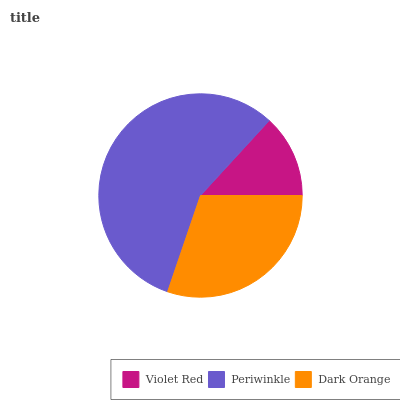Is Violet Red the minimum?
Answer yes or no. Yes. Is Periwinkle the maximum?
Answer yes or no. Yes. Is Dark Orange the minimum?
Answer yes or no. No. Is Dark Orange the maximum?
Answer yes or no. No. Is Periwinkle greater than Dark Orange?
Answer yes or no. Yes. Is Dark Orange less than Periwinkle?
Answer yes or no. Yes. Is Dark Orange greater than Periwinkle?
Answer yes or no. No. Is Periwinkle less than Dark Orange?
Answer yes or no. No. Is Dark Orange the high median?
Answer yes or no. Yes. Is Dark Orange the low median?
Answer yes or no. Yes. Is Violet Red the high median?
Answer yes or no. No. Is Violet Red the low median?
Answer yes or no. No. 